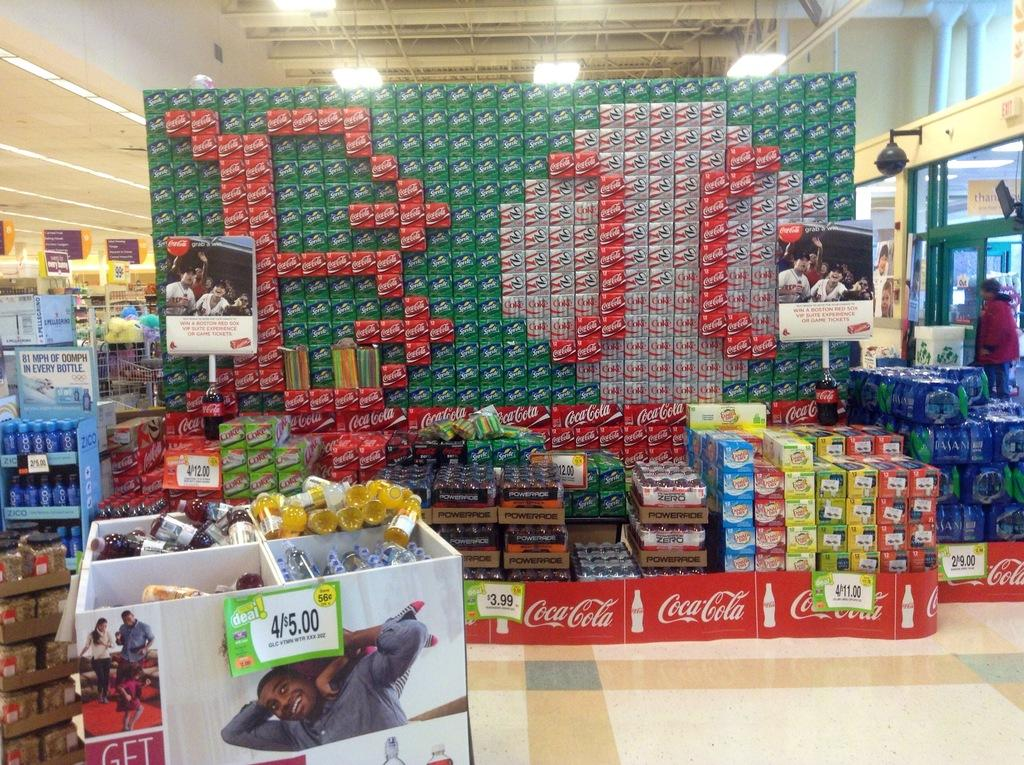What type of establishment is depicted in the image? There is a store in the image. What kind of products can be found in the store? The store contains stationary items. How many stamps are visible on the shirt in the image? There is no shirt or stamps present in the image; it only features a store with stationary items. 